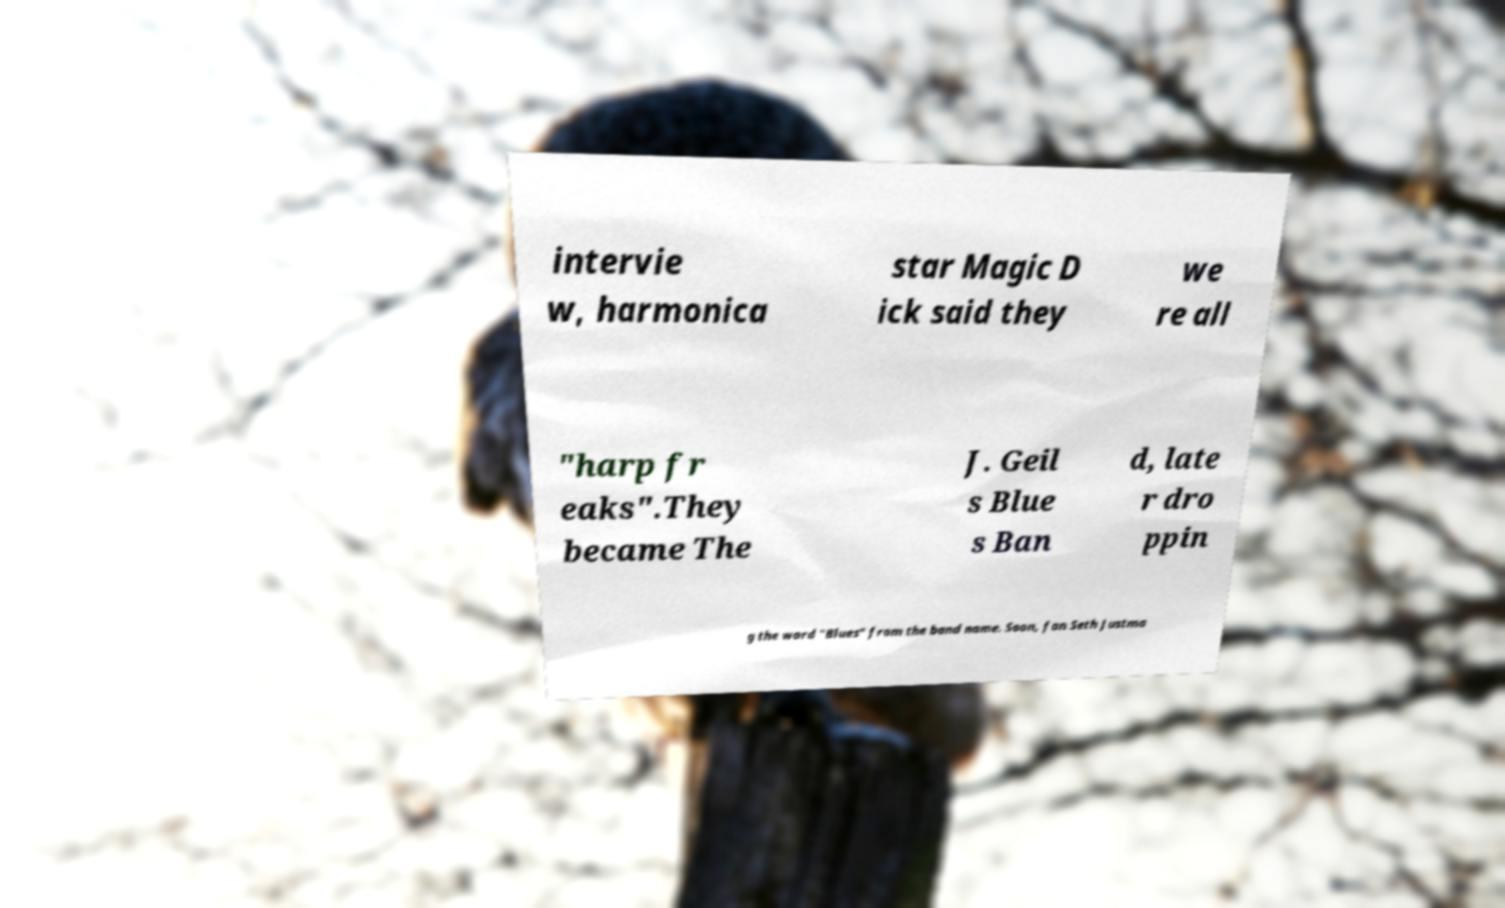Could you assist in decoding the text presented in this image and type it out clearly? intervie w, harmonica star Magic D ick said they we re all "harp fr eaks".They became The J. Geil s Blue s Ban d, late r dro ppin g the word "Blues" from the band name. Soon, fan Seth Justma 